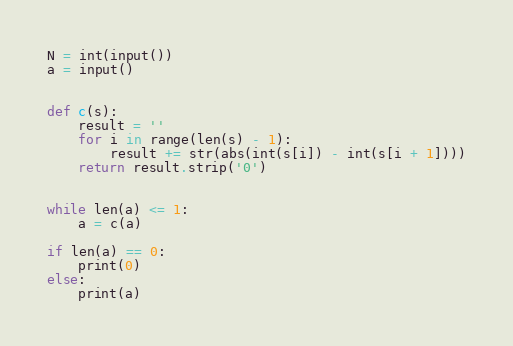<code> <loc_0><loc_0><loc_500><loc_500><_Python_>N = int(input())
a = input()


def c(s):
    result = ''
    for i in range(len(s) - 1):
        result += str(abs(int(s[i]) - int(s[i + 1])))
    return result.strip('0')


while len(a) <= 1:
    a = c(a)

if len(a) == 0:
    print(0)
else:
    print(a)
</code> 